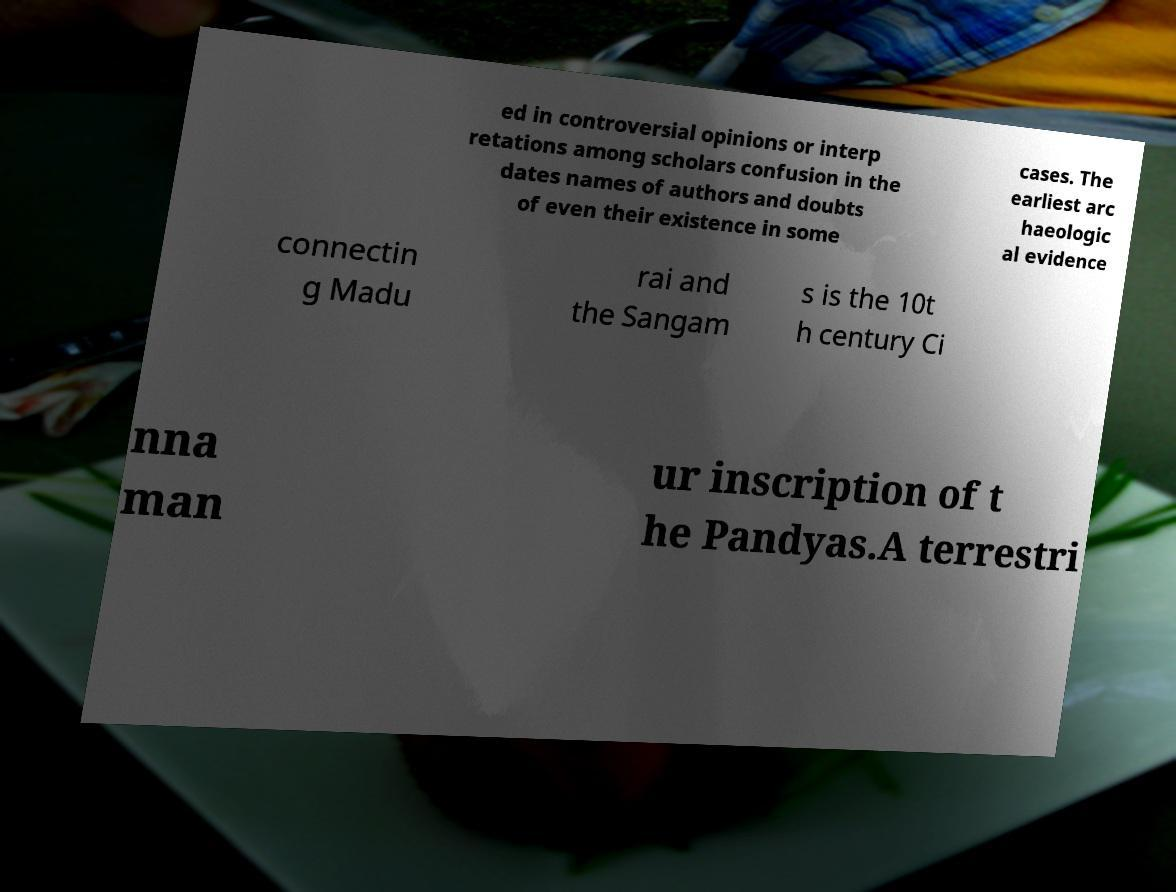Could you extract and type out the text from this image? ed in controversial opinions or interp retations among scholars confusion in the dates names of authors and doubts of even their existence in some cases. The earliest arc haeologic al evidence connectin g Madu rai and the Sangam s is the 10t h century Ci nna man ur inscription of t he Pandyas.A terrestri 